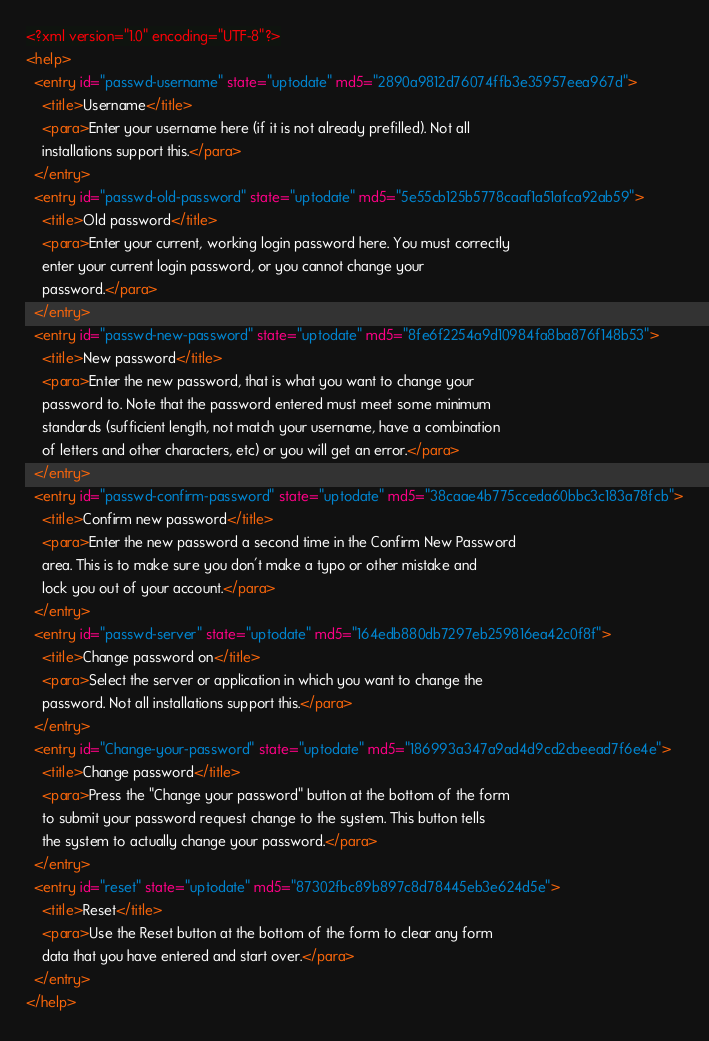Convert code to text. <code><loc_0><loc_0><loc_500><loc_500><_XML_><?xml version="1.0" encoding="UTF-8"?>
<help>
  <entry id="passwd-username" state="uptodate" md5="2890a9812d76074ffb3e35957eea967d">
    <title>Username</title>
    <para>Enter your username here (if it is not already prefilled). Not all
    installations support this.</para>
  </entry>
  <entry id="passwd-old-password" state="uptodate" md5="5e55cb125b5778caaf1a51afca92ab59">
    <title>Old password</title>
    <para>Enter your current, working login password here. You must correctly
    enter your current login password, or you cannot change your
    password.</para>
  </entry>
  <entry id="passwd-new-password" state="uptodate" md5="8fe6f2254a9d10984fa8ba876f148b53">
    <title>New password</title>
    <para>Enter the new password, that is what you want to change your
    password to. Note that the password entered must meet some minimum
    standards (sufficient length, not match your username, have a combination
    of letters and other characters, etc) or you will get an error.</para>
  </entry>
  <entry id="passwd-confirm-password" state="uptodate" md5="38caae4b775cceda60bbc3c183a78fcb">
    <title>Confirm new password</title>
    <para>Enter the new password a second time in the Confirm New Password
    area. This is to make sure you don't make a typo or other mistake and
    lock you out of your account.</para>
  </entry>
  <entry id="passwd-server" state="uptodate" md5="164edb880db7297eb259816ea42c0f8f">
    <title>Change password on</title>
    <para>Select the server or application in which you want to change the
    password. Not all installations support this.</para>
  </entry>
  <entry id="Change-your-password" state="uptodate" md5="186993a347a9ad4d9cd2cbeead7f6e4e">
    <title>Change password</title>
    <para>Press the "Change your password" button at the bottom of the form
    to submit your password request change to the system. This button tells
    the system to actually change your password.</para>
  </entry>
  <entry id="reset" state="uptodate" md5="87302fbc89b897c8d78445eb3e624d5e">
    <title>Reset</title>
    <para>Use the Reset button at the bottom of the form to clear any form
    data that you have entered and start over.</para>
  </entry>
</help>
</code> 